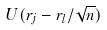Convert formula to latex. <formula><loc_0><loc_0><loc_500><loc_500>U ( r _ { j } - r _ { l } / \sqrt { n } )</formula> 